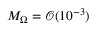Convert formula to latex. <formula><loc_0><loc_0><loc_500><loc_500>M _ { \Omega } = \mathcal { O } ( 1 0 ^ { - 3 } )</formula> 